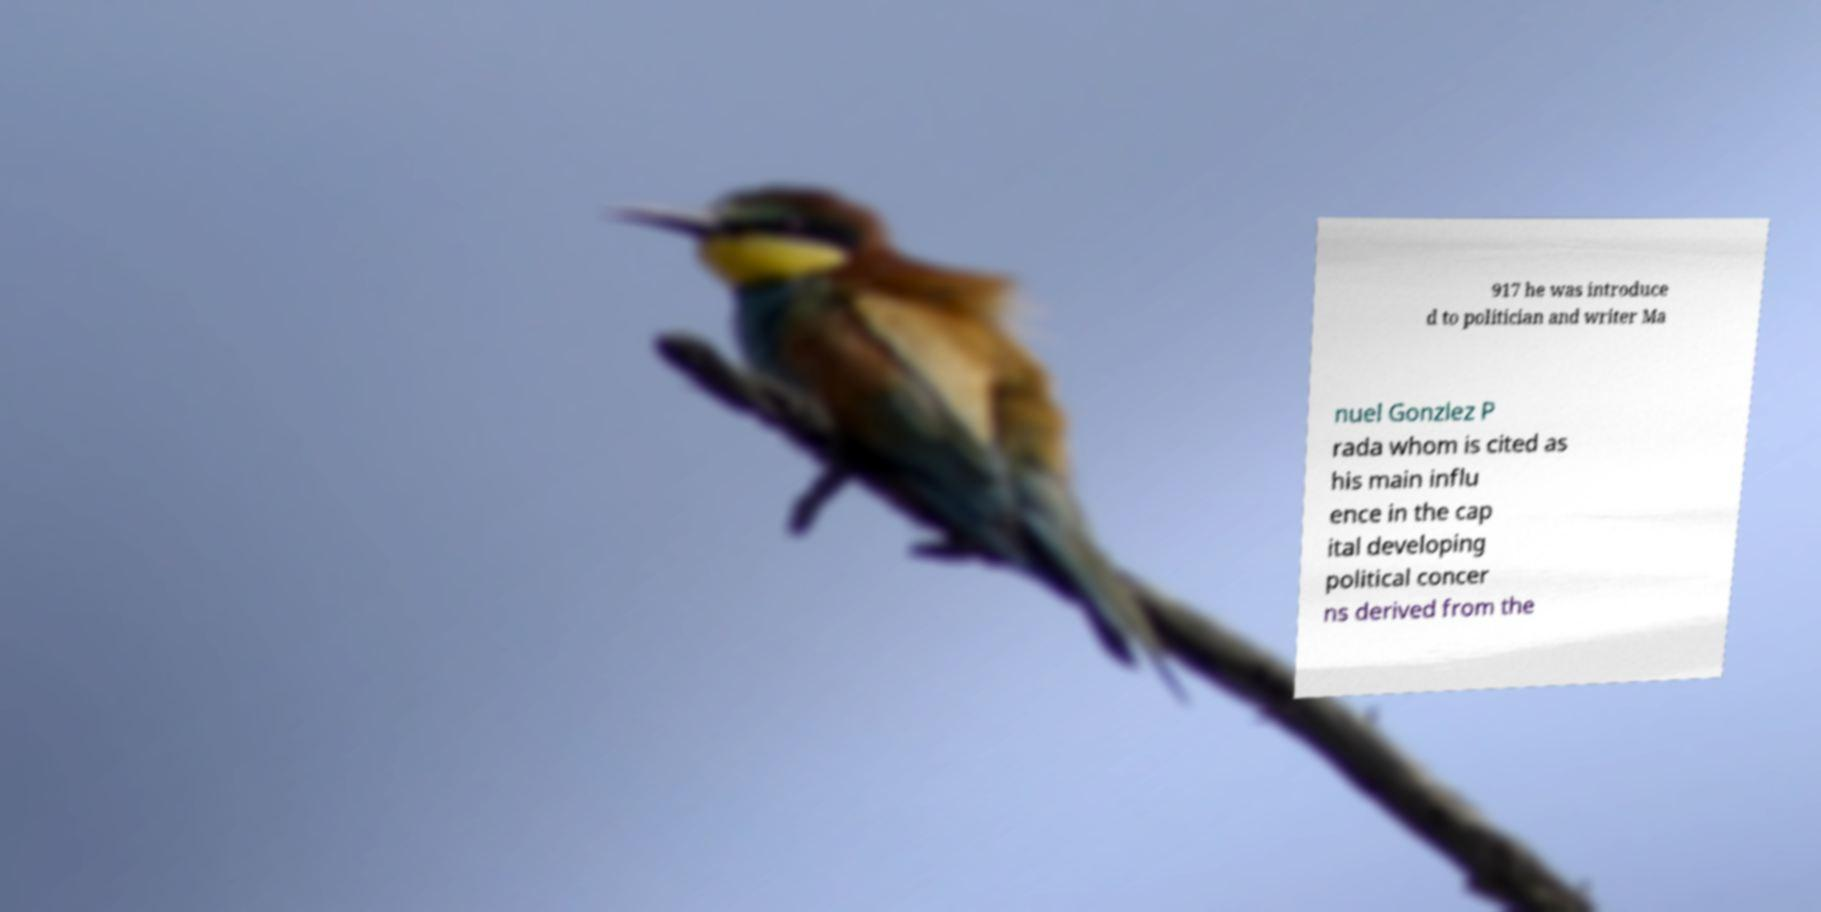Could you extract and type out the text from this image? 917 he was introduce d to politician and writer Ma nuel Gonzlez P rada whom is cited as his main influ ence in the cap ital developing political concer ns derived from the 